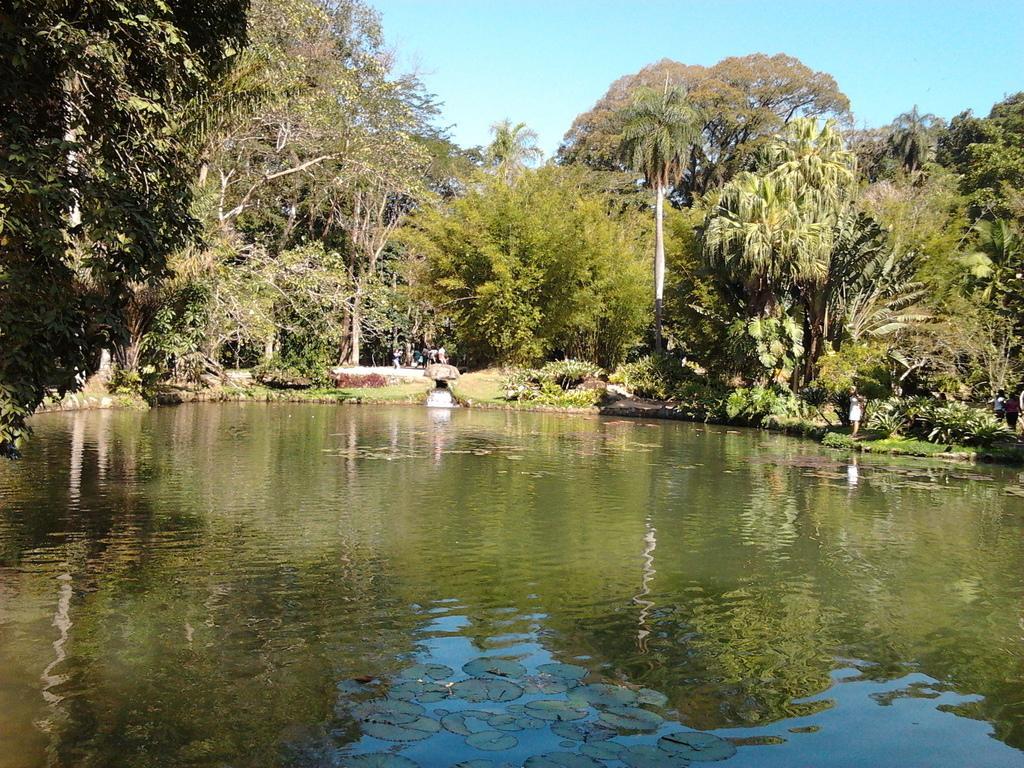Can you describe this image briefly? In this image I can see the water. On both sides I can see many trees. To the right I can see few people. In the background I can see the pole and the sky. 